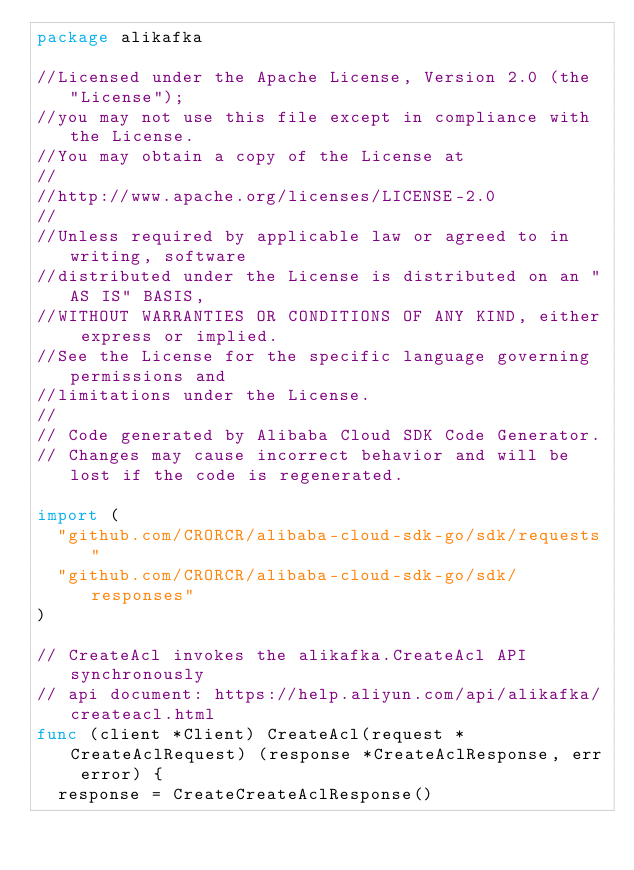<code> <loc_0><loc_0><loc_500><loc_500><_Go_>package alikafka

//Licensed under the Apache License, Version 2.0 (the "License");
//you may not use this file except in compliance with the License.
//You may obtain a copy of the License at
//
//http://www.apache.org/licenses/LICENSE-2.0
//
//Unless required by applicable law or agreed to in writing, software
//distributed under the License is distributed on an "AS IS" BASIS,
//WITHOUT WARRANTIES OR CONDITIONS OF ANY KIND, either express or implied.
//See the License for the specific language governing permissions and
//limitations under the License.
//
// Code generated by Alibaba Cloud SDK Code Generator.
// Changes may cause incorrect behavior and will be lost if the code is regenerated.

import (
	"github.com/CRORCR/alibaba-cloud-sdk-go/sdk/requests"
	"github.com/CRORCR/alibaba-cloud-sdk-go/sdk/responses"
)

// CreateAcl invokes the alikafka.CreateAcl API synchronously
// api document: https://help.aliyun.com/api/alikafka/createacl.html
func (client *Client) CreateAcl(request *CreateAclRequest) (response *CreateAclResponse, err error) {
	response = CreateCreateAclResponse()</code> 